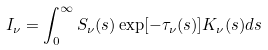<formula> <loc_0><loc_0><loc_500><loc_500>I _ { \nu } = \int ^ { \infty } _ { 0 } S _ { \nu } ( s ) \exp [ - \tau _ { \nu } ( s ) ] K _ { \nu } ( s ) d s</formula> 